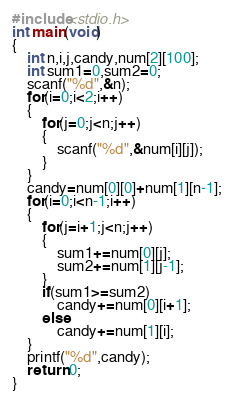<code> <loc_0><loc_0><loc_500><loc_500><_C_>#include<stdio.h>
int main(void)
{
	int n,i,j,candy,num[2][100];
	int sum1=0,sum2=0;
	scanf("%d",&n);
	for(i=0;i<2;i++)
	{
		for(j=0;j<n;j++)
		{
			scanf("%d",&num[i][j]);
		}
	}
	candy=num[0][0]+num[1][n-1];
	for(i=0;i<n-1;i++)
	{
		for(j=i+1;j<n;j++)
		{
			sum1+=num[0][j];
			sum2+=num[1][j-1];
		}
		if(sum1>=sum2)
			candy+=num[0][i+1]; 
		else
			candy+=num[1][i];
    }
    printf("%d",candy);
    return 0;
}</code> 